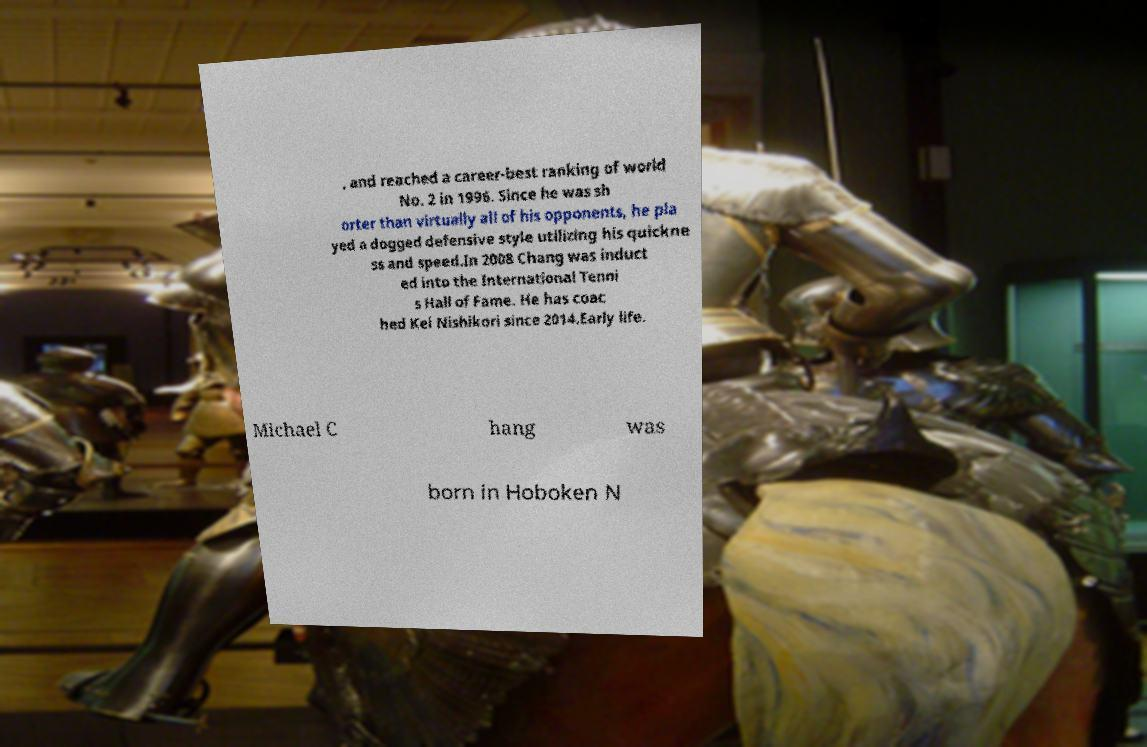Could you extract and type out the text from this image? , and reached a career-best ranking of world No. 2 in 1996. Since he was sh orter than virtually all of his opponents, he pla yed a dogged defensive style utilizing his quickne ss and speed.In 2008 Chang was induct ed into the International Tenni s Hall of Fame. He has coac hed Kei Nishikori since 2014.Early life. Michael C hang was born in Hoboken N 